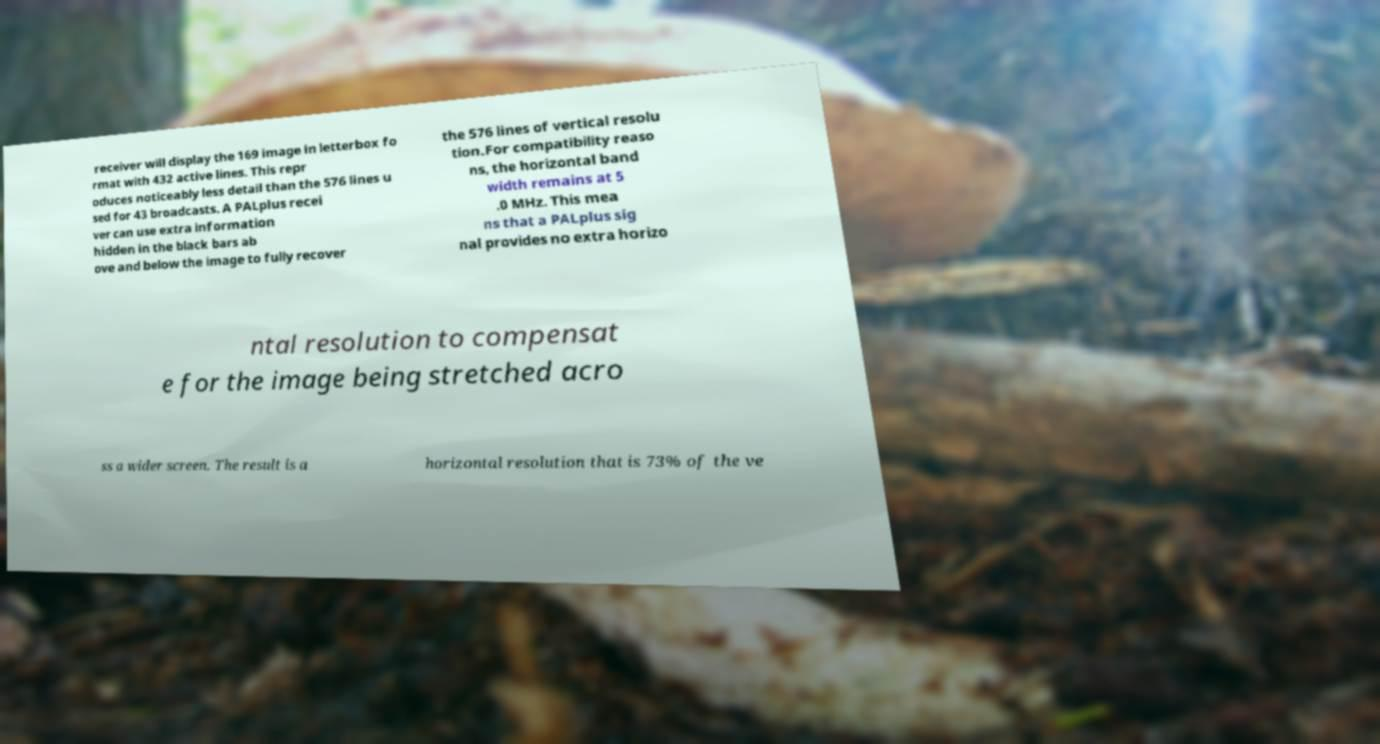Please read and relay the text visible in this image. What does it say? receiver will display the 169 image in letterbox fo rmat with 432 active lines. This repr oduces noticeably less detail than the 576 lines u sed for 43 broadcasts. A PALplus recei ver can use extra information hidden in the black bars ab ove and below the image to fully recover the 576 lines of vertical resolu tion.For compatibility reaso ns, the horizontal band width remains at 5 .0 MHz. This mea ns that a PALplus sig nal provides no extra horizo ntal resolution to compensat e for the image being stretched acro ss a wider screen. The result is a horizontal resolution that is 73% of the ve 